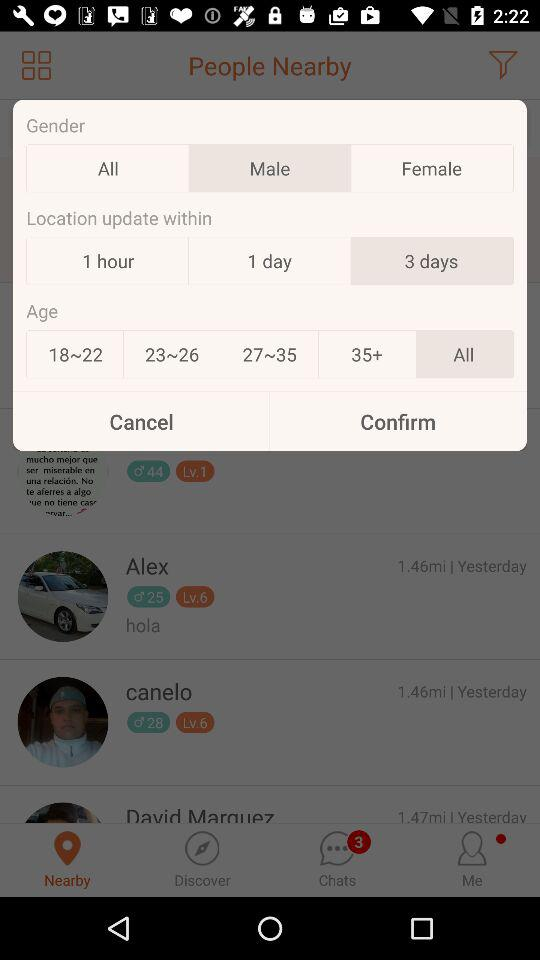How many location update options are there?
Answer the question using a single word or phrase. 3 